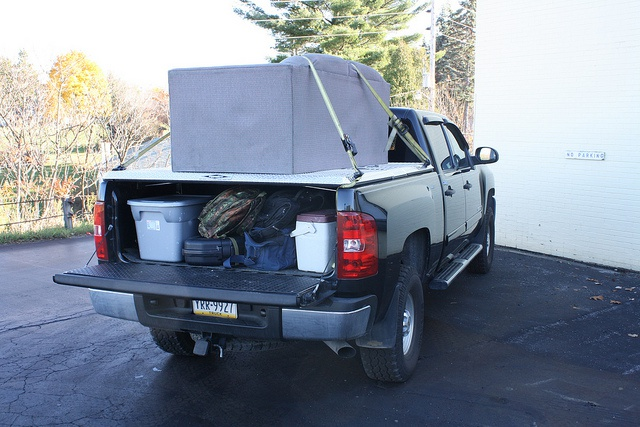Describe the objects in this image and their specific colors. I can see truck in white, black, darkgray, and navy tones, couch in white, darkgray, and gray tones, backpack in white, black, gray, and purple tones, backpack in white, black, navy, darkblue, and gray tones, and suitcase in white, navy, black, darkblue, and gray tones in this image. 